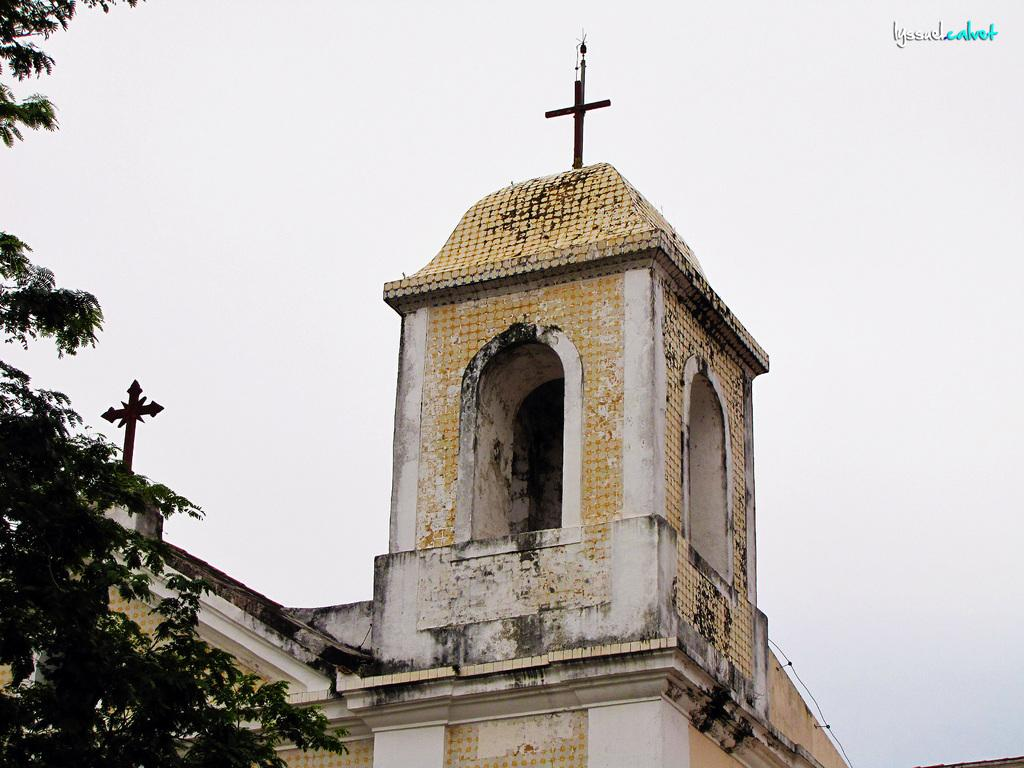What type of building is depicted in the image? There is a building with a cross on top in the image. Are there any other structures or objects near the building? Yes, there is a tree beside the building in the image. Can you describe any additional features of the image? There is a watermark at the top right side of the image. What type of iron is being used to maintain the field in the image? There is no iron or field present in the image; it features a building with a cross on top and a tree beside it. 